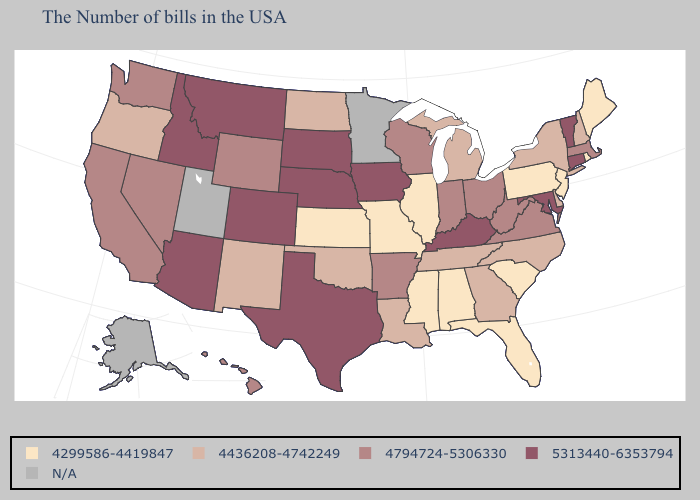What is the value of Alabama?
Write a very short answer. 4299586-4419847. Name the states that have a value in the range 4794724-5306330?
Keep it brief. Massachusetts, Virginia, West Virginia, Ohio, Indiana, Wisconsin, Arkansas, Wyoming, Nevada, California, Washington, Hawaii. What is the lowest value in the MidWest?
Short answer required. 4299586-4419847. Among the states that border Maryland , does West Virginia have the highest value?
Keep it brief. Yes. Which states have the lowest value in the USA?
Write a very short answer. Maine, Rhode Island, New Jersey, Pennsylvania, South Carolina, Florida, Alabama, Illinois, Mississippi, Missouri, Kansas. Does Maine have the lowest value in the USA?
Be succinct. Yes. Does Illinois have the highest value in the MidWest?
Write a very short answer. No. What is the value of New Jersey?
Short answer required. 4299586-4419847. Does Mississippi have the lowest value in the USA?
Quick response, please. Yes. Does Nebraska have the highest value in the USA?
Keep it brief. Yes. Among the states that border Alabama , does Mississippi have the lowest value?
Short answer required. Yes. Name the states that have a value in the range 4436208-4742249?
Answer briefly. New Hampshire, New York, Delaware, North Carolina, Georgia, Michigan, Tennessee, Louisiana, Oklahoma, North Dakota, New Mexico, Oregon. Name the states that have a value in the range 4299586-4419847?
Answer briefly. Maine, Rhode Island, New Jersey, Pennsylvania, South Carolina, Florida, Alabama, Illinois, Mississippi, Missouri, Kansas. Which states have the lowest value in the USA?
Quick response, please. Maine, Rhode Island, New Jersey, Pennsylvania, South Carolina, Florida, Alabama, Illinois, Mississippi, Missouri, Kansas. Name the states that have a value in the range 4436208-4742249?
Keep it brief. New Hampshire, New York, Delaware, North Carolina, Georgia, Michigan, Tennessee, Louisiana, Oklahoma, North Dakota, New Mexico, Oregon. 